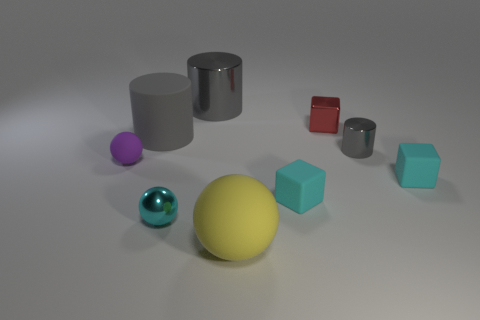What number of other objects are there of the same color as the large rubber cylinder?
Make the answer very short. 2. How many big metallic cylinders are the same color as the matte cylinder?
Give a very brief answer. 1. There is a rubber sphere to the right of the tiny purple matte ball; is there a gray cylinder in front of it?
Give a very brief answer. No. What number of other objects are there of the same shape as the tiny red metallic object?
Ensure brevity in your answer.  2. There is a gray object that is on the right side of the big yellow object; is it the same shape as the matte object behind the purple ball?
Offer a very short reply. Yes. How many big rubber things are in front of the tiny matte thing that is in front of the tiny rubber block that is to the right of the red block?
Ensure brevity in your answer.  1. The metal block is what color?
Make the answer very short. Red. How many other things are there of the same size as the red metallic cube?
Provide a succinct answer. 5. There is a small purple object that is the same shape as the small cyan shiny object; what material is it?
Make the answer very short. Rubber. What is the material of the big gray cylinder to the left of the small ball that is to the right of the rubber ball that is behind the cyan sphere?
Provide a short and direct response. Rubber. 